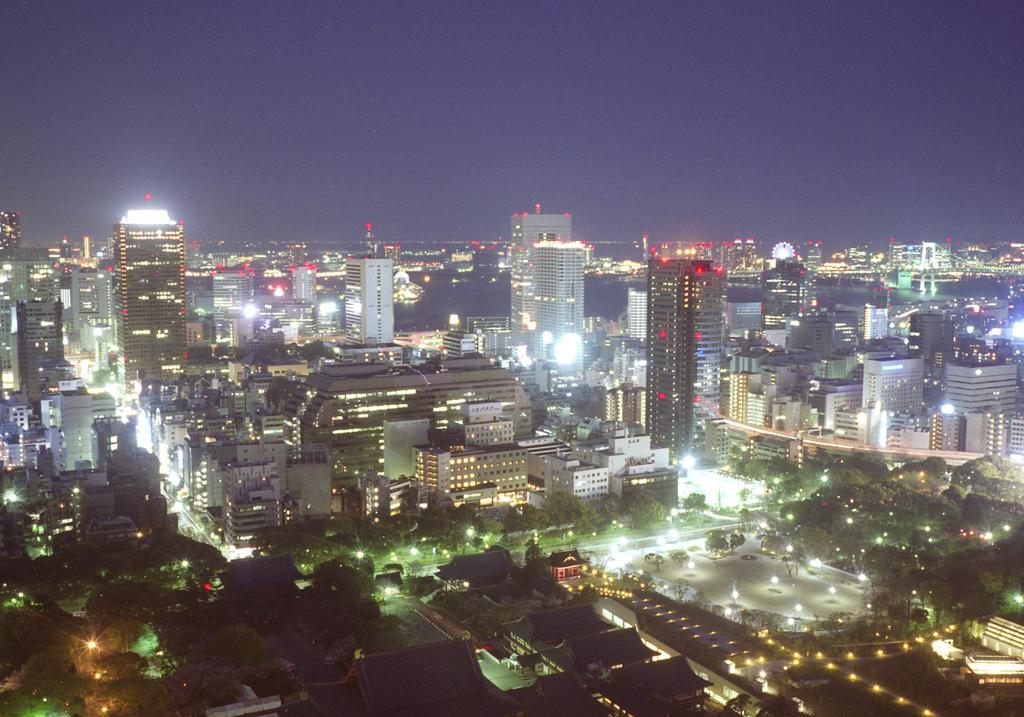What type of structures can be seen in the foreground of the image? There are houses in the foreground of the image. What else is present in the foreground of the image besides the houses? Lights are present in the foreground of the image. What type of buildings can be seen in the middle of the image? There are tall buildings in the middle of the image. What is visible at the top of the image? The sky is visible at the top of the image. How many toys can be seen in the image? There are no toys present in the image. What is the height of the pocket in the image? There is no pocket present in the image. 